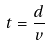Convert formula to latex. <formula><loc_0><loc_0><loc_500><loc_500>t = \frac { d } { v }</formula> 